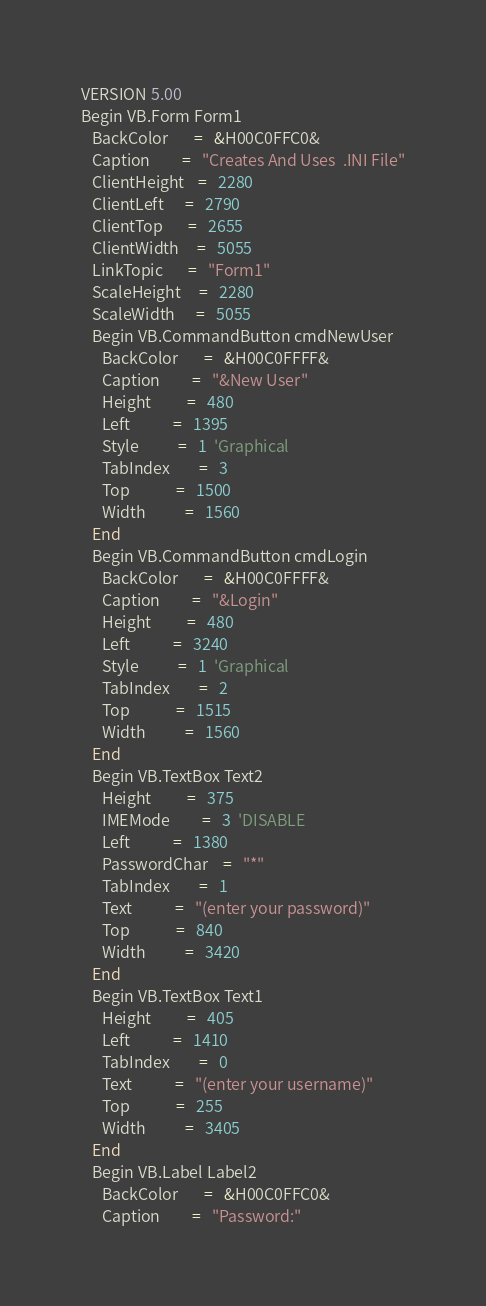Convert code to text. <code><loc_0><loc_0><loc_500><loc_500><_VisualBasic_>VERSION 5.00
Begin VB.Form Form1 
   BackColor       =   &H00C0FFC0&
   Caption         =   "Creates And Uses  .INI File"
   ClientHeight    =   2280
   ClientLeft      =   2790
   ClientTop       =   2655
   ClientWidth     =   5055
   LinkTopic       =   "Form1"
   ScaleHeight     =   2280
   ScaleWidth      =   5055
   Begin VB.CommandButton cmdNewUser 
      BackColor       =   &H00C0FFFF&
      Caption         =   "&New User"
      Height          =   480
      Left            =   1395
      Style           =   1  'Graphical
      TabIndex        =   3
      Top             =   1500
      Width           =   1560
   End
   Begin VB.CommandButton cmdLogin 
      BackColor       =   &H00C0FFFF&
      Caption         =   "&Login"
      Height          =   480
      Left            =   3240
      Style           =   1  'Graphical
      TabIndex        =   2
      Top             =   1515
      Width           =   1560
   End
   Begin VB.TextBox Text2 
      Height          =   375
      IMEMode         =   3  'DISABLE
      Left            =   1380
      PasswordChar    =   "*"
      TabIndex        =   1
      Text            =   "(enter your password)"
      Top             =   840
      Width           =   3420
   End
   Begin VB.TextBox Text1 
      Height          =   405
      Left            =   1410
      TabIndex        =   0
      Text            =   "(enter your username)"
      Top             =   255
      Width           =   3405
   End
   Begin VB.Label Label2 
      BackColor       =   &H00C0FFC0&
      Caption         =   "Password:"</code> 